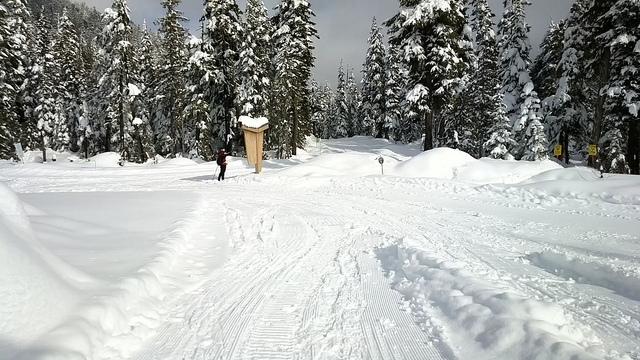Is anyone skiing?
Write a very short answer. Yes. What covers the ground?
Quick response, please. Snow. Was this road recently driven on?
Keep it brief. Yes. 